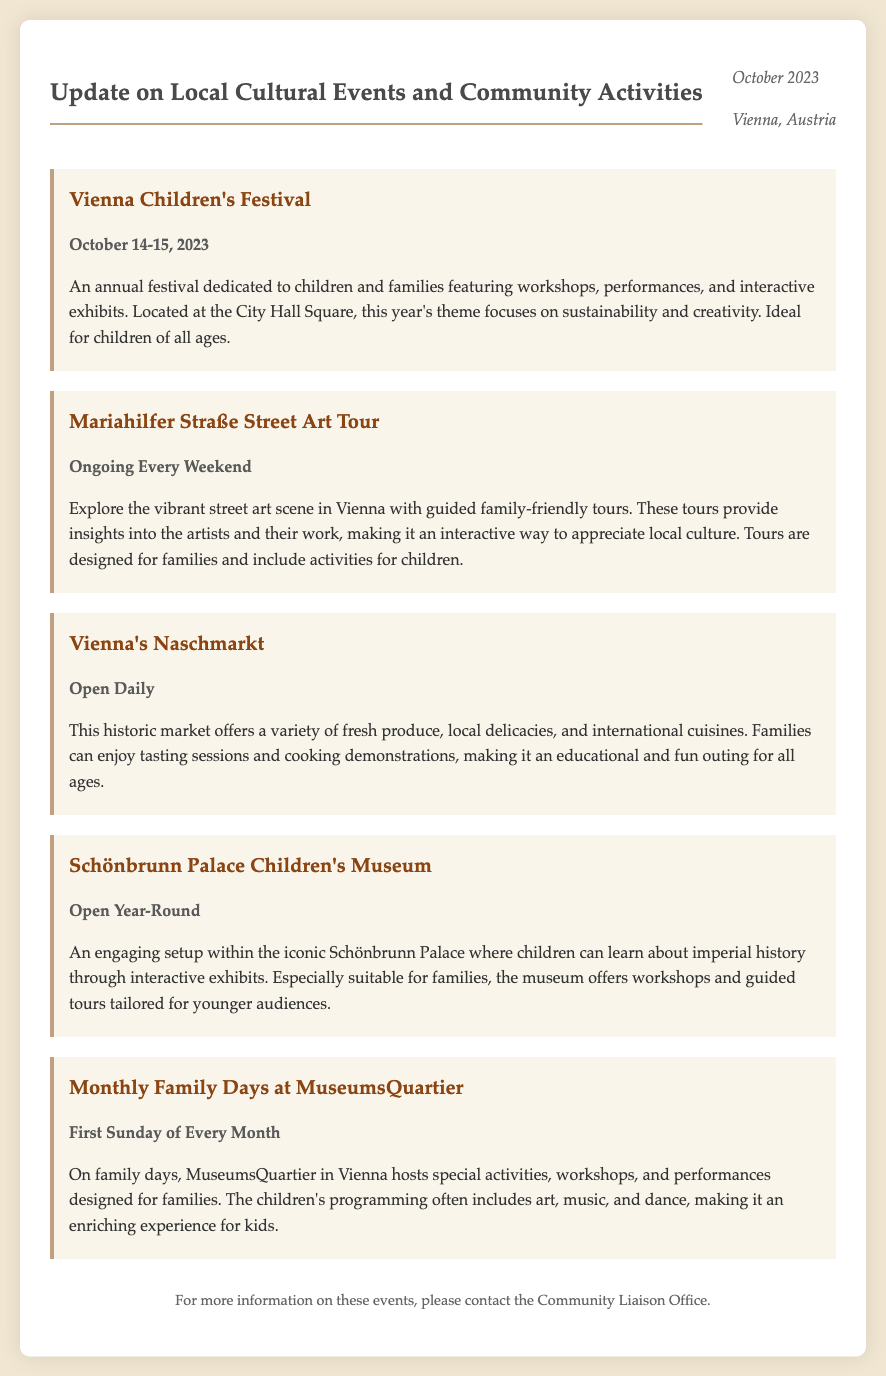What is the title of the memo? The title of the memo is given in bold at the top.
Answer: Update on Local Cultural Events and Community Activities What are the dates for the Vienna Children's Festival? The exact dates for the event are provided in the event description.
Answer: October 14-15, 2023 What is the theme of this year's Vienna Children's Festival? The theme is specified in the description of the event.
Answer: Sustainability and creativity What type of tours are offered on Mariahilfer Straße? The type of tours provided is mentioned in the document.
Answer: Street Art Tour When do Monthly Family Days occur at MuseumsQuartier? The timing for these family days is detailed in the corresponding section.
Answer: First Sunday of Every Month Which museum has interactive exhibits about imperial history? The specific museum is highlighted in the event description.
Answer: Schönbrunn Palace Children's Museum Which market is open daily? The market that is mentioned in the memo has daily availability.
Answer: Vienna's Naschmarkt What organization can be contacted for more information about the events? The name of the office is given in the footer of the memo.
Answer: Community Liaison Office 